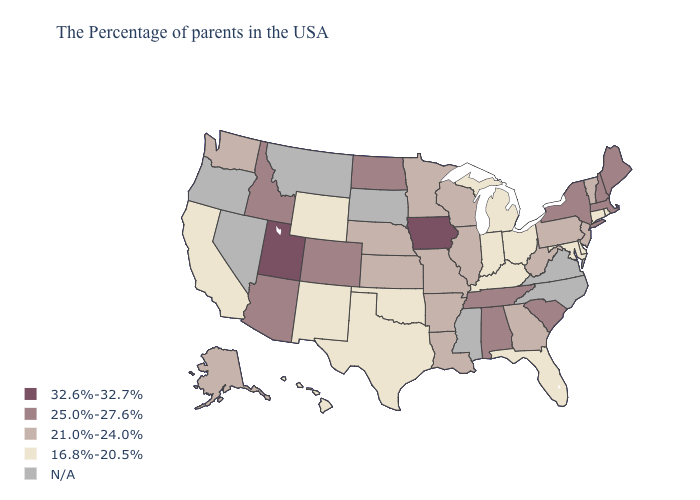What is the highest value in the MidWest ?
Keep it brief. 32.6%-32.7%. Among the states that border South Dakota , which have the lowest value?
Give a very brief answer. Wyoming. Name the states that have a value in the range 25.0%-27.6%?
Give a very brief answer. Maine, Massachusetts, New Hampshire, New York, South Carolina, Alabama, Tennessee, North Dakota, Colorado, Arizona, Idaho. Is the legend a continuous bar?
Be succinct. No. What is the highest value in states that border Wyoming?
Keep it brief. 32.6%-32.7%. What is the lowest value in the USA?
Answer briefly. 16.8%-20.5%. What is the value of New Hampshire?
Short answer required. 25.0%-27.6%. What is the value of Hawaii?
Concise answer only. 16.8%-20.5%. Name the states that have a value in the range 25.0%-27.6%?
Short answer required. Maine, Massachusetts, New Hampshire, New York, South Carolina, Alabama, Tennessee, North Dakota, Colorado, Arizona, Idaho. How many symbols are there in the legend?
Concise answer only. 5. What is the value of Missouri?
Be succinct. 21.0%-24.0%. What is the value of Michigan?
Be succinct. 16.8%-20.5%. Does Florida have the highest value in the USA?
Write a very short answer. No. Does Rhode Island have the lowest value in the Northeast?
Write a very short answer. Yes. What is the highest value in states that border Idaho?
Write a very short answer. 32.6%-32.7%. 